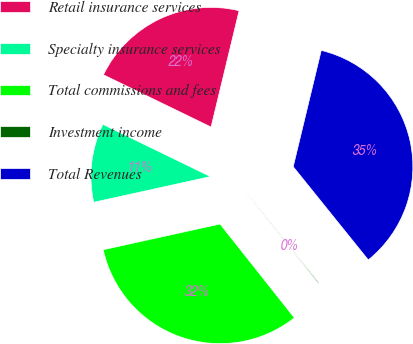<chart> <loc_0><loc_0><loc_500><loc_500><pie_chart><fcel>Retail insurance services<fcel>Specialty insurance services<fcel>Total commissions and fees<fcel>Investment income<fcel>Total Revenues<nl><fcel>21.57%<fcel>10.64%<fcel>32.21%<fcel>0.13%<fcel>35.44%<nl></chart> 